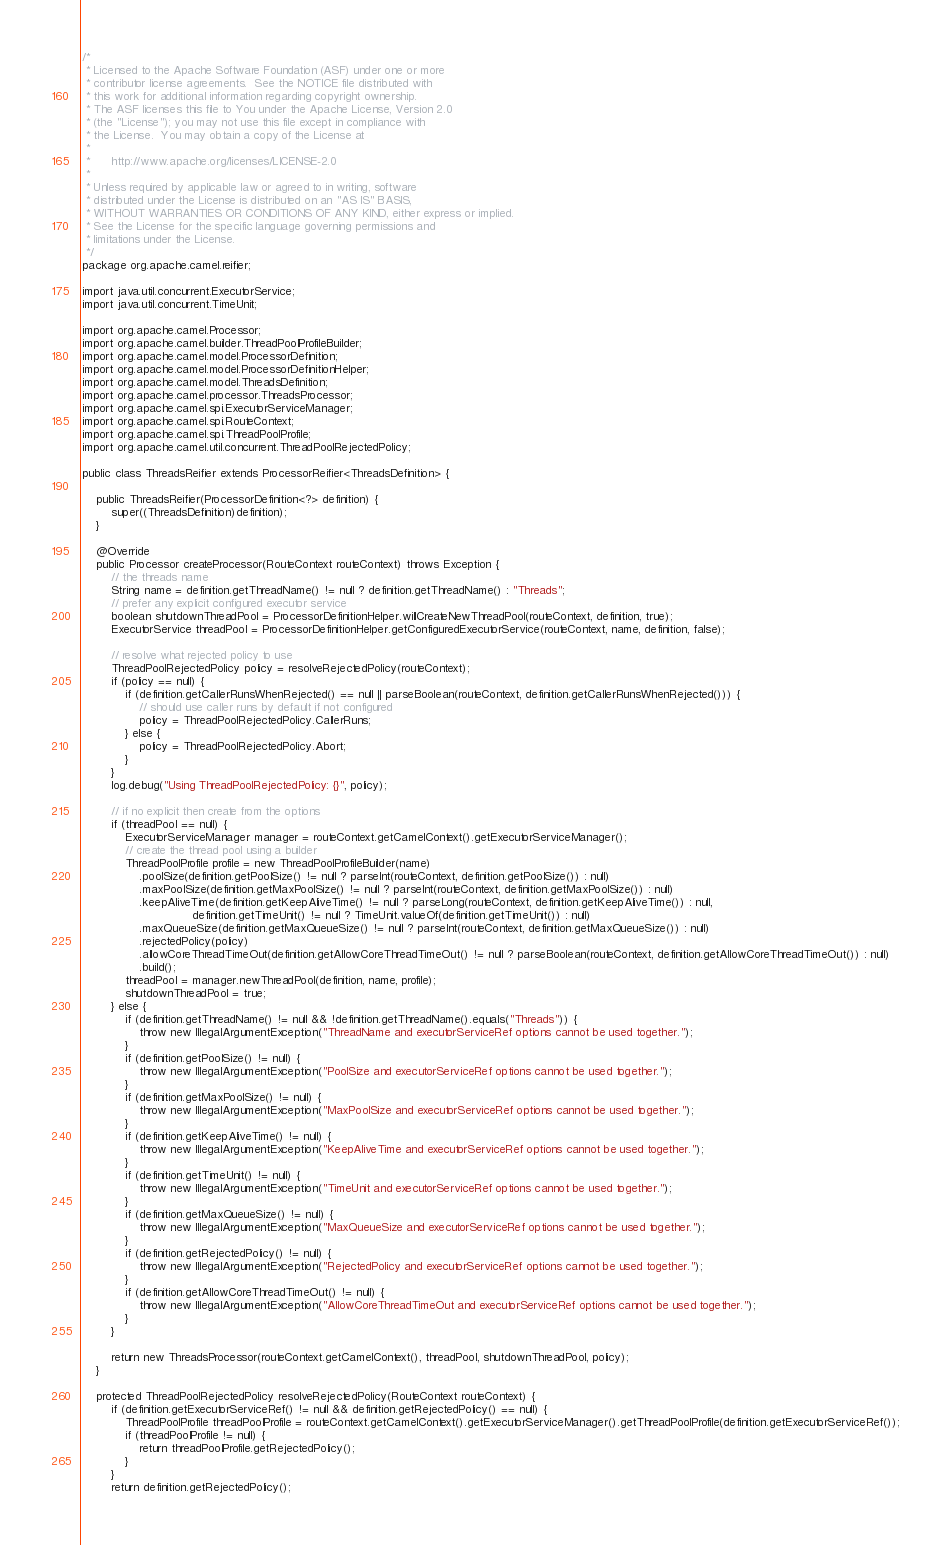Convert code to text. <code><loc_0><loc_0><loc_500><loc_500><_Java_>/*
 * Licensed to the Apache Software Foundation (ASF) under one or more
 * contributor license agreements.  See the NOTICE file distributed with
 * this work for additional information regarding copyright ownership.
 * The ASF licenses this file to You under the Apache License, Version 2.0
 * (the "License"); you may not use this file except in compliance with
 * the License.  You may obtain a copy of the License at
 *
 *      http://www.apache.org/licenses/LICENSE-2.0
 *
 * Unless required by applicable law or agreed to in writing, software
 * distributed under the License is distributed on an "AS IS" BASIS,
 * WITHOUT WARRANTIES OR CONDITIONS OF ANY KIND, either express or implied.
 * See the License for the specific language governing permissions and
 * limitations under the License.
 */
package org.apache.camel.reifier;

import java.util.concurrent.ExecutorService;
import java.util.concurrent.TimeUnit;

import org.apache.camel.Processor;
import org.apache.camel.builder.ThreadPoolProfileBuilder;
import org.apache.camel.model.ProcessorDefinition;
import org.apache.camel.model.ProcessorDefinitionHelper;
import org.apache.camel.model.ThreadsDefinition;
import org.apache.camel.processor.ThreadsProcessor;
import org.apache.camel.spi.ExecutorServiceManager;
import org.apache.camel.spi.RouteContext;
import org.apache.camel.spi.ThreadPoolProfile;
import org.apache.camel.util.concurrent.ThreadPoolRejectedPolicy;

public class ThreadsReifier extends ProcessorReifier<ThreadsDefinition> {

    public ThreadsReifier(ProcessorDefinition<?> definition) {
        super((ThreadsDefinition)definition);
    }

    @Override
    public Processor createProcessor(RouteContext routeContext) throws Exception {
        // the threads name
        String name = definition.getThreadName() != null ? definition.getThreadName() : "Threads";
        // prefer any explicit configured executor service
        boolean shutdownThreadPool = ProcessorDefinitionHelper.willCreateNewThreadPool(routeContext, definition, true);
        ExecutorService threadPool = ProcessorDefinitionHelper.getConfiguredExecutorService(routeContext, name, definition, false);

        // resolve what rejected policy to use
        ThreadPoolRejectedPolicy policy = resolveRejectedPolicy(routeContext);
        if (policy == null) {
            if (definition.getCallerRunsWhenRejected() == null || parseBoolean(routeContext, definition.getCallerRunsWhenRejected())) {
                // should use caller runs by default if not configured
                policy = ThreadPoolRejectedPolicy.CallerRuns;
            } else {
                policy = ThreadPoolRejectedPolicy.Abort;
            }
        }
        log.debug("Using ThreadPoolRejectedPolicy: {}", policy);

        // if no explicit then create from the options
        if (threadPool == null) {
            ExecutorServiceManager manager = routeContext.getCamelContext().getExecutorServiceManager();
            // create the thread pool using a builder
            ThreadPoolProfile profile = new ThreadPoolProfileBuilder(name)
                .poolSize(definition.getPoolSize() != null ? parseInt(routeContext, definition.getPoolSize()) : null)
                .maxPoolSize(definition.getMaxPoolSize() != null ? parseInt(routeContext, definition.getMaxPoolSize()) : null)
                .keepAliveTime(definition.getKeepAliveTime() != null ? parseLong(routeContext, definition.getKeepAliveTime()) : null,
                               definition.getTimeUnit() != null ? TimeUnit.valueOf(definition.getTimeUnit()) : null)
                .maxQueueSize(definition.getMaxQueueSize() != null ? parseInt(routeContext, definition.getMaxQueueSize()) : null)
                .rejectedPolicy(policy)
                .allowCoreThreadTimeOut(definition.getAllowCoreThreadTimeOut() != null ? parseBoolean(routeContext, definition.getAllowCoreThreadTimeOut()) : null)
                .build();
            threadPool = manager.newThreadPool(definition, name, profile);
            shutdownThreadPool = true;
        } else {
            if (definition.getThreadName() != null && !definition.getThreadName().equals("Threads")) {
                throw new IllegalArgumentException("ThreadName and executorServiceRef options cannot be used together.");
            }
            if (definition.getPoolSize() != null) {
                throw new IllegalArgumentException("PoolSize and executorServiceRef options cannot be used together.");
            }
            if (definition.getMaxPoolSize() != null) {
                throw new IllegalArgumentException("MaxPoolSize and executorServiceRef options cannot be used together.");
            }
            if (definition.getKeepAliveTime() != null) {
                throw new IllegalArgumentException("KeepAliveTime and executorServiceRef options cannot be used together.");
            }
            if (definition.getTimeUnit() != null) {
                throw new IllegalArgumentException("TimeUnit and executorServiceRef options cannot be used together.");
            }
            if (definition.getMaxQueueSize() != null) {
                throw new IllegalArgumentException("MaxQueueSize and executorServiceRef options cannot be used together.");
            }
            if (definition.getRejectedPolicy() != null) {
                throw new IllegalArgumentException("RejectedPolicy and executorServiceRef options cannot be used together.");
            }
            if (definition.getAllowCoreThreadTimeOut() != null) {
                throw new IllegalArgumentException("AllowCoreThreadTimeOut and executorServiceRef options cannot be used together.");
            }
        }

        return new ThreadsProcessor(routeContext.getCamelContext(), threadPool, shutdownThreadPool, policy);
    }

    protected ThreadPoolRejectedPolicy resolveRejectedPolicy(RouteContext routeContext) {
        if (definition.getExecutorServiceRef() != null && definition.getRejectedPolicy() == null) {
            ThreadPoolProfile threadPoolProfile = routeContext.getCamelContext().getExecutorServiceManager().getThreadPoolProfile(definition.getExecutorServiceRef());
            if (threadPoolProfile != null) {
                return threadPoolProfile.getRejectedPolicy();
            }
        }
        return definition.getRejectedPolicy();</code> 